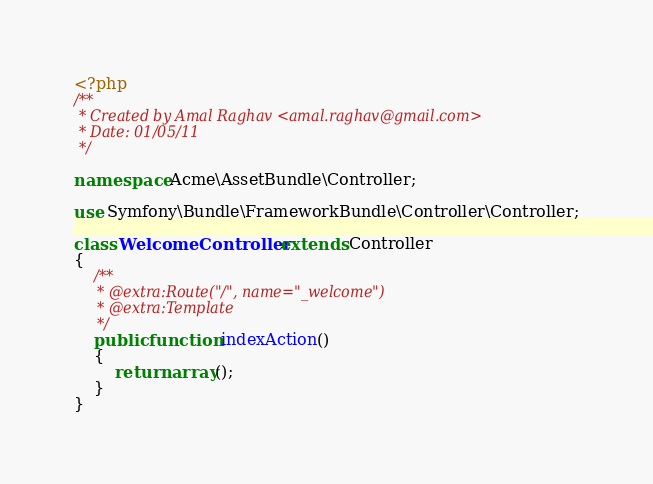<code> <loc_0><loc_0><loc_500><loc_500><_PHP_><?php
/**
 * Created by Amal Raghav <amal.raghav@gmail.com>
 * Date: 01/05/11
 */

namespace Acme\AssetBundle\Controller;

use Symfony\Bundle\FrameworkBundle\Controller\Controller;

class WelcomeController extends Controller
{
    /**
     * @extra:Route("/", name="_welcome")
     * @extra:Template
     */
    public function indexAction()
    {
        return array();
    }
}
</code> 